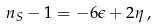Convert formula to latex. <formula><loc_0><loc_0><loc_500><loc_500>n _ { S } - 1 = - 6 \epsilon + 2 \eta \, ,</formula> 